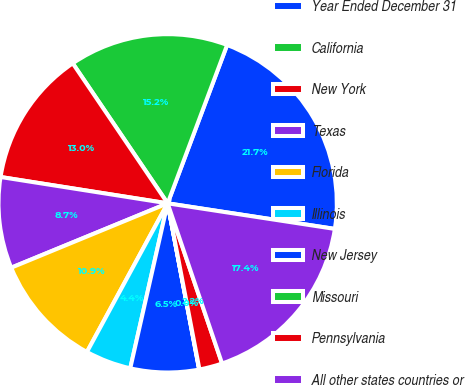Convert chart. <chart><loc_0><loc_0><loc_500><loc_500><pie_chart><fcel>Year Ended December 31<fcel>California<fcel>New York<fcel>Texas<fcel>Florida<fcel>Illinois<fcel>New Jersey<fcel>Missouri<fcel>Pennsylvania<fcel>All other states countries or<nl><fcel>21.7%<fcel>15.2%<fcel>13.03%<fcel>8.7%<fcel>10.87%<fcel>4.37%<fcel>6.53%<fcel>0.03%<fcel>2.2%<fcel>17.37%<nl></chart> 